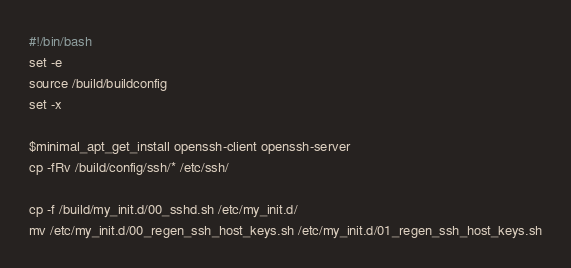<code> <loc_0><loc_0><loc_500><loc_500><_Bash_>#!/bin/bash
set -e
source /build/buildconfig
set -x

$minimal_apt_get_install openssh-client openssh-server
cp -fRv /build/config/ssh/* /etc/ssh/

cp -f /build/my_init.d/00_sshd.sh /etc/my_init.d/
mv /etc/my_init.d/00_regen_ssh_host_keys.sh /etc/my_init.d/01_regen_ssh_host_keys.sh
</code> 